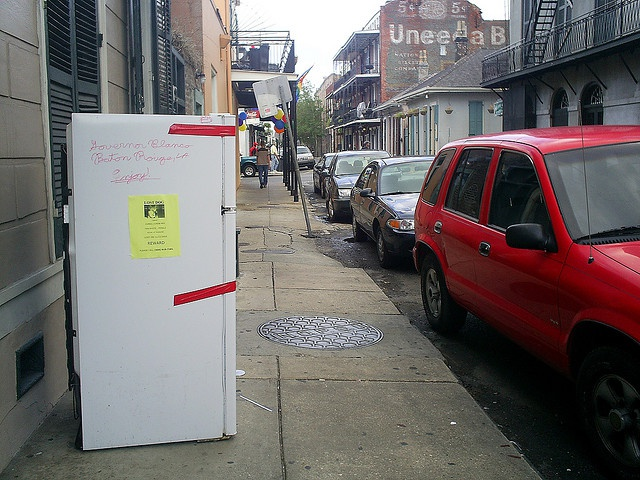Describe the objects in this image and their specific colors. I can see refrigerator in gray, darkgray, and lightgray tones, car in gray, black, and maroon tones, car in gray, black, darkgray, and lightgray tones, car in gray, darkgray, black, and lightgray tones, and people in gray and black tones in this image. 